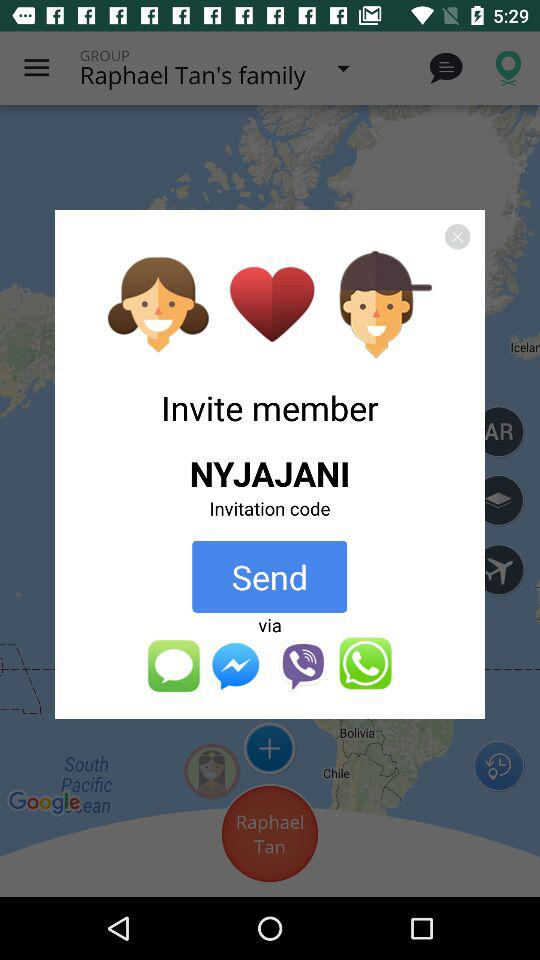What is the invitation code? The invitation code is "NYJAJANI". 